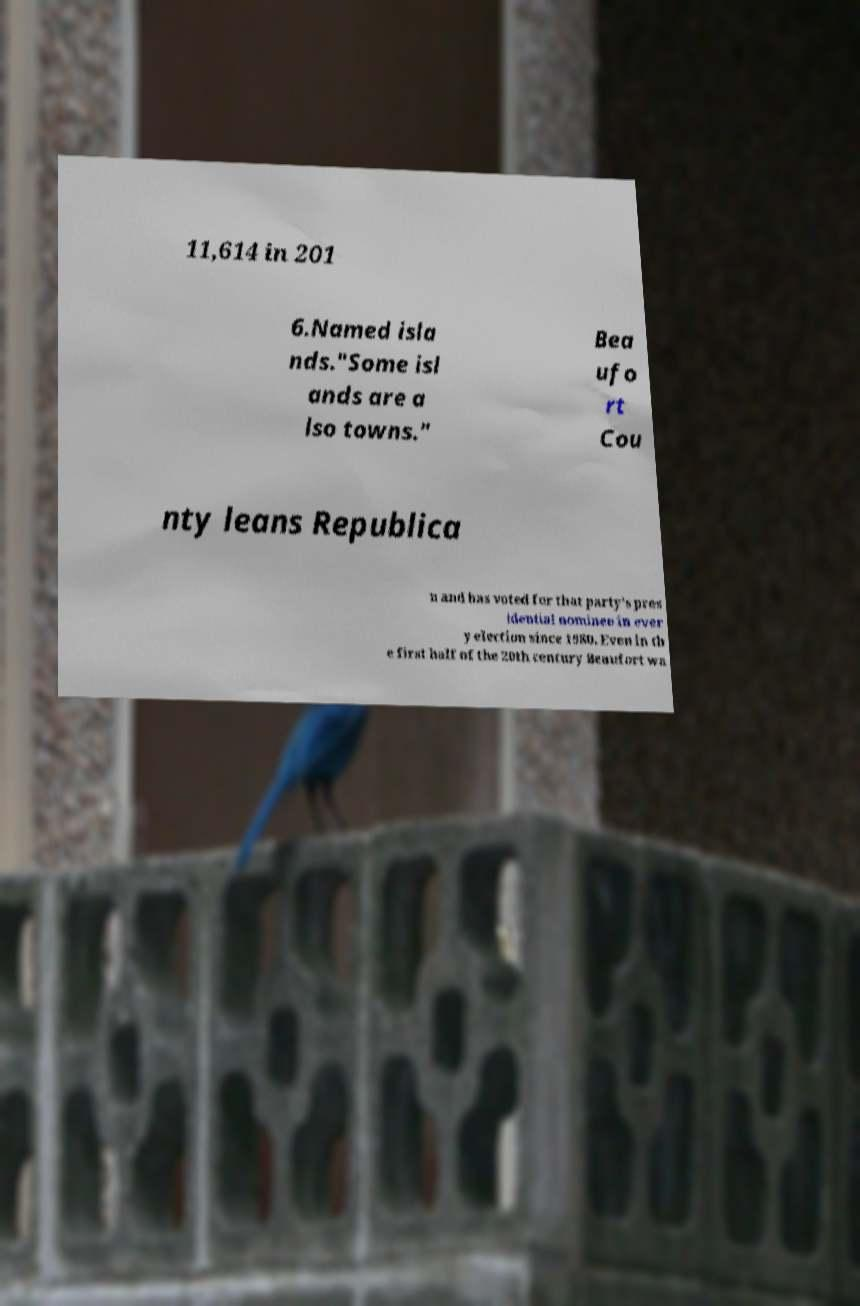What messages or text are displayed in this image? I need them in a readable, typed format. 11,614 in 201 6.Named isla nds."Some isl ands are a lso towns." Bea ufo rt Cou nty leans Republica n and has voted for that party's pres idential nominee in ever y election since 1980. Even in th e first half of the 20th century Beaufort wa 